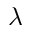<formula> <loc_0><loc_0><loc_500><loc_500>\lambda</formula> 